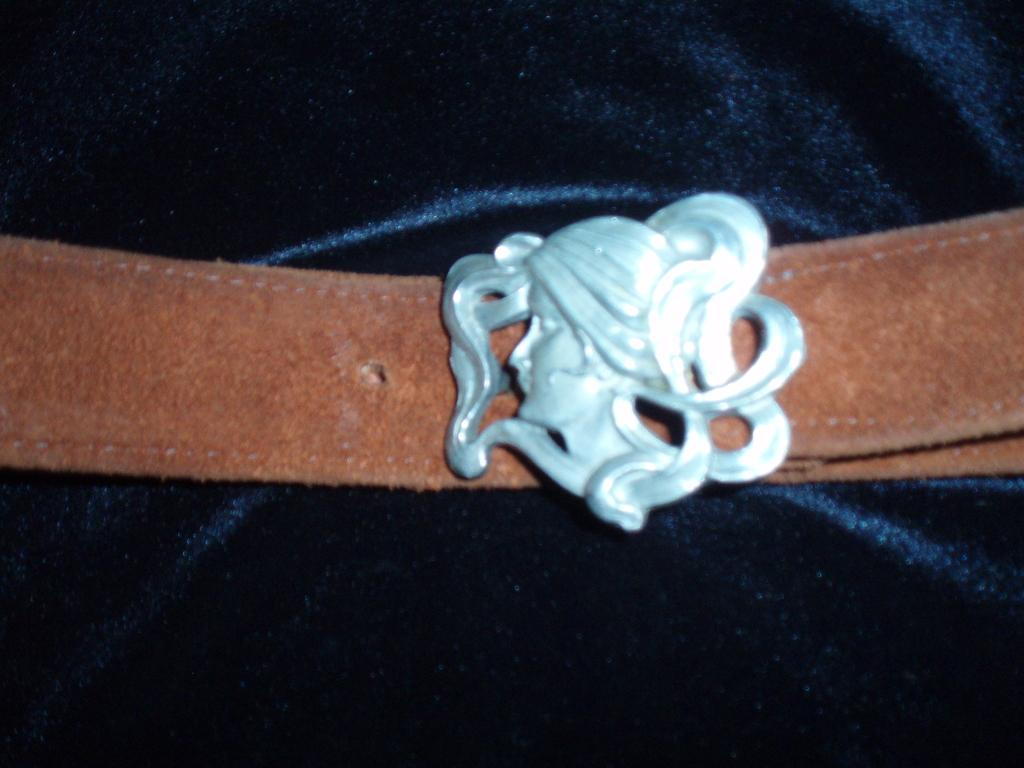What type of accessory is present in the image? There is a belt in the image. What is attached to the belt? The belt has a buckle attached to it. What material is the belt made of? The belt is made of cloth. What type of footwear is visible in the image? There is no footwear present in the image; it only features a belt made of cloth with a buckle attached to it. 